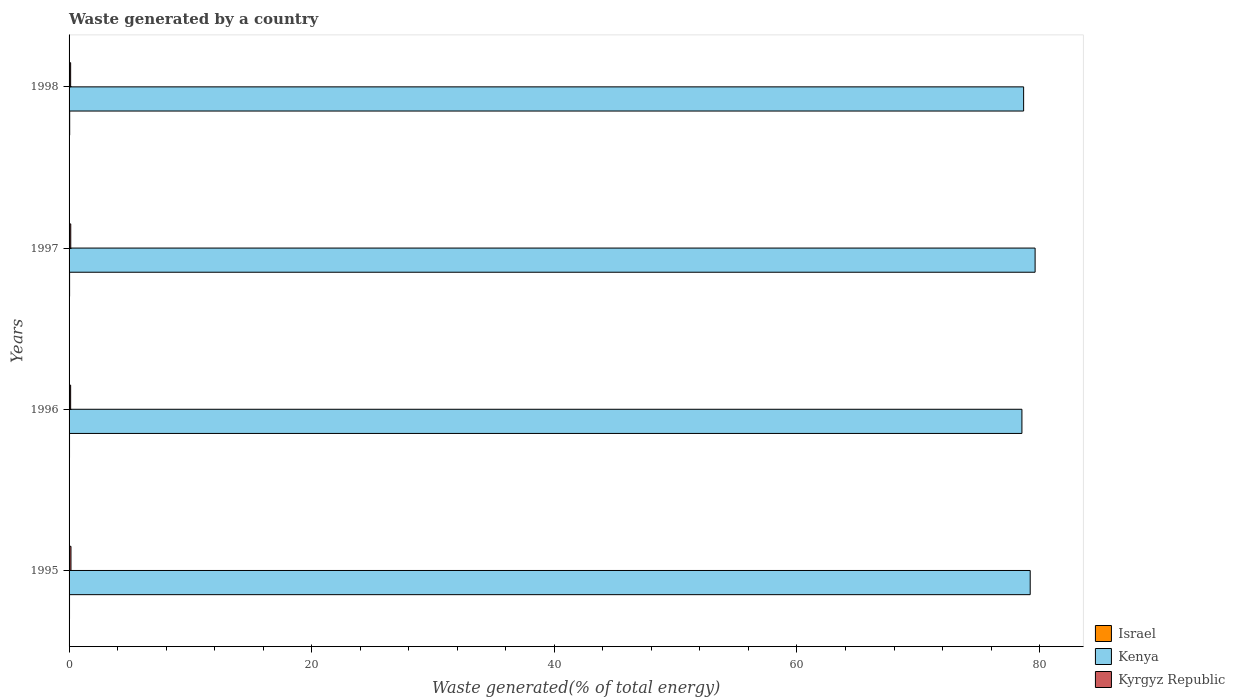How many different coloured bars are there?
Your answer should be compact. 3. Are the number of bars on each tick of the Y-axis equal?
Provide a succinct answer. Yes. How many bars are there on the 4th tick from the top?
Ensure brevity in your answer.  3. How many bars are there on the 3rd tick from the bottom?
Offer a very short reply. 3. In how many cases, is the number of bars for a given year not equal to the number of legend labels?
Offer a terse response. 0. What is the total waste generated in Kyrgyz Republic in 1997?
Your answer should be compact. 0.14. Across all years, what is the maximum total waste generated in Israel?
Provide a succinct answer. 0.05. Across all years, what is the minimum total waste generated in Kenya?
Make the answer very short. 78.55. In which year was the total waste generated in Kyrgyz Republic maximum?
Provide a succinct answer. 1995. What is the total total waste generated in Israel in the graph?
Provide a short and direct response. 0.17. What is the difference between the total waste generated in Israel in 1995 and that in 1996?
Provide a succinct answer. 0. What is the difference between the total waste generated in Kyrgyz Republic in 1995 and the total waste generated in Kenya in 1997?
Your response must be concise. -79.48. What is the average total waste generated in Kyrgyz Republic per year?
Provide a succinct answer. 0.14. In the year 1998, what is the difference between the total waste generated in Kyrgyz Republic and total waste generated in Kenya?
Your response must be concise. -78.56. In how many years, is the total waste generated in Israel greater than 60 %?
Your response must be concise. 0. What is the ratio of the total waste generated in Kenya in 1997 to that in 1998?
Provide a short and direct response. 1.01. What is the difference between the highest and the second highest total waste generated in Kenya?
Keep it short and to the point. 0.41. What is the difference between the highest and the lowest total waste generated in Israel?
Provide a succinct answer. 0.01. What does the 2nd bar from the top in 1997 represents?
Offer a very short reply. Kenya. Is it the case that in every year, the sum of the total waste generated in Kenya and total waste generated in Kyrgyz Republic is greater than the total waste generated in Israel?
Your response must be concise. Yes. Are all the bars in the graph horizontal?
Your answer should be compact. Yes. How many years are there in the graph?
Offer a very short reply. 4. Are the values on the major ticks of X-axis written in scientific E-notation?
Keep it short and to the point. No. How are the legend labels stacked?
Offer a very short reply. Vertical. What is the title of the graph?
Your answer should be compact. Waste generated by a country. What is the label or title of the X-axis?
Make the answer very short. Waste generated(% of total energy). What is the label or title of the Y-axis?
Provide a short and direct response. Years. What is the Waste generated(% of total energy) of Israel in 1995?
Give a very brief answer. 0.04. What is the Waste generated(% of total energy) of Kenya in 1995?
Your answer should be very brief. 79.23. What is the Waste generated(% of total energy) in Kyrgyz Republic in 1995?
Keep it short and to the point. 0.16. What is the Waste generated(% of total energy) of Israel in 1996?
Make the answer very short. 0.04. What is the Waste generated(% of total energy) in Kenya in 1996?
Make the answer very short. 78.55. What is the Waste generated(% of total energy) of Kyrgyz Republic in 1996?
Ensure brevity in your answer.  0.13. What is the Waste generated(% of total energy) in Israel in 1997?
Your answer should be compact. 0.04. What is the Waste generated(% of total energy) in Kenya in 1997?
Offer a very short reply. 79.63. What is the Waste generated(% of total energy) in Kyrgyz Republic in 1997?
Give a very brief answer. 0.14. What is the Waste generated(% of total energy) in Israel in 1998?
Your response must be concise. 0.05. What is the Waste generated(% of total energy) in Kenya in 1998?
Ensure brevity in your answer.  78.69. What is the Waste generated(% of total energy) in Kyrgyz Republic in 1998?
Give a very brief answer. 0.13. Across all years, what is the maximum Waste generated(% of total energy) of Israel?
Offer a terse response. 0.05. Across all years, what is the maximum Waste generated(% of total energy) in Kenya?
Ensure brevity in your answer.  79.63. Across all years, what is the maximum Waste generated(% of total energy) of Kyrgyz Republic?
Offer a terse response. 0.16. Across all years, what is the minimum Waste generated(% of total energy) in Israel?
Your answer should be very brief. 0.04. Across all years, what is the minimum Waste generated(% of total energy) in Kenya?
Give a very brief answer. 78.55. Across all years, what is the minimum Waste generated(% of total energy) in Kyrgyz Republic?
Offer a very short reply. 0.13. What is the total Waste generated(% of total energy) in Israel in the graph?
Provide a succinct answer. 0.17. What is the total Waste generated(% of total energy) in Kenya in the graph?
Your response must be concise. 316.09. What is the total Waste generated(% of total energy) of Kyrgyz Republic in the graph?
Ensure brevity in your answer.  0.55. What is the difference between the Waste generated(% of total energy) of Israel in 1995 and that in 1996?
Give a very brief answer. 0. What is the difference between the Waste generated(% of total energy) of Kenya in 1995 and that in 1996?
Keep it short and to the point. 0.68. What is the difference between the Waste generated(% of total energy) of Kyrgyz Republic in 1995 and that in 1996?
Ensure brevity in your answer.  0.03. What is the difference between the Waste generated(% of total energy) of Israel in 1995 and that in 1997?
Your response must be concise. -0. What is the difference between the Waste generated(% of total energy) in Kenya in 1995 and that in 1997?
Keep it short and to the point. -0.41. What is the difference between the Waste generated(% of total energy) in Kyrgyz Republic in 1995 and that in 1997?
Ensure brevity in your answer.  0.02. What is the difference between the Waste generated(% of total energy) of Israel in 1995 and that in 1998?
Provide a short and direct response. -0.01. What is the difference between the Waste generated(% of total energy) of Kenya in 1995 and that in 1998?
Ensure brevity in your answer.  0.54. What is the difference between the Waste generated(% of total energy) in Kyrgyz Republic in 1995 and that in 1998?
Keep it short and to the point. 0.03. What is the difference between the Waste generated(% of total energy) of Israel in 1996 and that in 1997?
Provide a short and direct response. -0.01. What is the difference between the Waste generated(% of total energy) of Kenya in 1996 and that in 1997?
Give a very brief answer. -1.09. What is the difference between the Waste generated(% of total energy) in Kyrgyz Republic in 1996 and that in 1997?
Your answer should be very brief. -0.01. What is the difference between the Waste generated(% of total energy) in Israel in 1996 and that in 1998?
Your answer should be very brief. -0.01. What is the difference between the Waste generated(% of total energy) in Kenya in 1996 and that in 1998?
Your answer should be very brief. -0.14. What is the difference between the Waste generated(% of total energy) in Israel in 1997 and that in 1998?
Keep it short and to the point. -0.01. What is the difference between the Waste generated(% of total energy) of Kenya in 1997 and that in 1998?
Ensure brevity in your answer.  0.95. What is the difference between the Waste generated(% of total energy) of Kyrgyz Republic in 1997 and that in 1998?
Offer a terse response. 0.01. What is the difference between the Waste generated(% of total energy) in Israel in 1995 and the Waste generated(% of total energy) in Kenya in 1996?
Provide a short and direct response. -78.51. What is the difference between the Waste generated(% of total energy) in Israel in 1995 and the Waste generated(% of total energy) in Kyrgyz Republic in 1996?
Provide a short and direct response. -0.09. What is the difference between the Waste generated(% of total energy) in Kenya in 1995 and the Waste generated(% of total energy) in Kyrgyz Republic in 1996?
Offer a very short reply. 79.1. What is the difference between the Waste generated(% of total energy) of Israel in 1995 and the Waste generated(% of total energy) of Kenya in 1997?
Offer a very short reply. -79.59. What is the difference between the Waste generated(% of total energy) in Israel in 1995 and the Waste generated(% of total energy) in Kyrgyz Republic in 1997?
Give a very brief answer. -0.1. What is the difference between the Waste generated(% of total energy) of Kenya in 1995 and the Waste generated(% of total energy) of Kyrgyz Republic in 1997?
Your answer should be very brief. 79.09. What is the difference between the Waste generated(% of total energy) of Israel in 1995 and the Waste generated(% of total energy) of Kenya in 1998?
Give a very brief answer. -78.65. What is the difference between the Waste generated(% of total energy) in Israel in 1995 and the Waste generated(% of total energy) in Kyrgyz Republic in 1998?
Give a very brief answer. -0.09. What is the difference between the Waste generated(% of total energy) of Kenya in 1995 and the Waste generated(% of total energy) of Kyrgyz Republic in 1998?
Give a very brief answer. 79.1. What is the difference between the Waste generated(% of total energy) in Israel in 1996 and the Waste generated(% of total energy) in Kenya in 1997?
Offer a terse response. -79.6. What is the difference between the Waste generated(% of total energy) in Israel in 1996 and the Waste generated(% of total energy) in Kyrgyz Republic in 1997?
Offer a very short reply. -0.1. What is the difference between the Waste generated(% of total energy) of Kenya in 1996 and the Waste generated(% of total energy) of Kyrgyz Republic in 1997?
Ensure brevity in your answer.  78.41. What is the difference between the Waste generated(% of total energy) of Israel in 1996 and the Waste generated(% of total energy) of Kenya in 1998?
Your response must be concise. -78.65. What is the difference between the Waste generated(% of total energy) in Israel in 1996 and the Waste generated(% of total energy) in Kyrgyz Republic in 1998?
Provide a succinct answer. -0.09. What is the difference between the Waste generated(% of total energy) of Kenya in 1996 and the Waste generated(% of total energy) of Kyrgyz Republic in 1998?
Provide a short and direct response. 78.42. What is the difference between the Waste generated(% of total energy) of Israel in 1997 and the Waste generated(% of total energy) of Kenya in 1998?
Your answer should be very brief. -78.64. What is the difference between the Waste generated(% of total energy) of Israel in 1997 and the Waste generated(% of total energy) of Kyrgyz Republic in 1998?
Your response must be concise. -0.09. What is the difference between the Waste generated(% of total energy) of Kenya in 1997 and the Waste generated(% of total energy) of Kyrgyz Republic in 1998?
Provide a succinct answer. 79.5. What is the average Waste generated(% of total energy) in Israel per year?
Make the answer very short. 0.04. What is the average Waste generated(% of total energy) in Kenya per year?
Ensure brevity in your answer.  79.02. What is the average Waste generated(% of total energy) of Kyrgyz Republic per year?
Keep it short and to the point. 0.14. In the year 1995, what is the difference between the Waste generated(% of total energy) of Israel and Waste generated(% of total energy) of Kenya?
Ensure brevity in your answer.  -79.19. In the year 1995, what is the difference between the Waste generated(% of total energy) of Israel and Waste generated(% of total energy) of Kyrgyz Republic?
Your answer should be compact. -0.12. In the year 1995, what is the difference between the Waste generated(% of total energy) of Kenya and Waste generated(% of total energy) of Kyrgyz Republic?
Make the answer very short. 79.07. In the year 1996, what is the difference between the Waste generated(% of total energy) of Israel and Waste generated(% of total energy) of Kenya?
Offer a very short reply. -78.51. In the year 1996, what is the difference between the Waste generated(% of total energy) of Israel and Waste generated(% of total energy) of Kyrgyz Republic?
Your answer should be compact. -0.09. In the year 1996, what is the difference between the Waste generated(% of total energy) in Kenya and Waste generated(% of total energy) in Kyrgyz Republic?
Ensure brevity in your answer.  78.42. In the year 1997, what is the difference between the Waste generated(% of total energy) of Israel and Waste generated(% of total energy) of Kenya?
Offer a very short reply. -79.59. In the year 1997, what is the difference between the Waste generated(% of total energy) of Israel and Waste generated(% of total energy) of Kyrgyz Republic?
Provide a succinct answer. -0.09. In the year 1997, what is the difference between the Waste generated(% of total energy) of Kenya and Waste generated(% of total energy) of Kyrgyz Republic?
Offer a very short reply. 79.49. In the year 1998, what is the difference between the Waste generated(% of total energy) of Israel and Waste generated(% of total energy) of Kenya?
Give a very brief answer. -78.63. In the year 1998, what is the difference between the Waste generated(% of total energy) of Israel and Waste generated(% of total energy) of Kyrgyz Republic?
Give a very brief answer. -0.08. In the year 1998, what is the difference between the Waste generated(% of total energy) in Kenya and Waste generated(% of total energy) in Kyrgyz Republic?
Make the answer very short. 78.56. What is the ratio of the Waste generated(% of total energy) of Israel in 1995 to that in 1996?
Keep it short and to the point. 1.03. What is the ratio of the Waste generated(% of total energy) in Kenya in 1995 to that in 1996?
Provide a short and direct response. 1.01. What is the ratio of the Waste generated(% of total energy) of Kyrgyz Republic in 1995 to that in 1996?
Ensure brevity in your answer.  1.2. What is the ratio of the Waste generated(% of total energy) of Israel in 1995 to that in 1997?
Make the answer very short. 0.89. What is the ratio of the Waste generated(% of total energy) in Kyrgyz Republic in 1995 to that in 1997?
Provide a succinct answer. 1.13. What is the ratio of the Waste generated(% of total energy) of Israel in 1995 to that in 1998?
Your response must be concise. 0.76. What is the ratio of the Waste generated(% of total energy) in Kyrgyz Republic in 1995 to that in 1998?
Provide a short and direct response. 1.2. What is the ratio of the Waste generated(% of total energy) of Israel in 1996 to that in 1997?
Make the answer very short. 0.86. What is the ratio of the Waste generated(% of total energy) in Kenya in 1996 to that in 1997?
Keep it short and to the point. 0.99. What is the ratio of the Waste generated(% of total energy) of Kyrgyz Republic in 1996 to that in 1997?
Your answer should be very brief. 0.94. What is the ratio of the Waste generated(% of total energy) in Israel in 1996 to that in 1998?
Offer a terse response. 0.74. What is the ratio of the Waste generated(% of total energy) in Kenya in 1996 to that in 1998?
Your response must be concise. 1. What is the ratio of the Waste generated(% of total energy) of Israel in 1997 to that in 1998?
Make the answer very short. 0.85. What is the ratio of the Waste generated(% of total energy) in Kyrgyz Republic in 1997 to that in 1998?
Offer a terse response. 1.06. What is the difference between the highest and the second highest Waste generated(% of total energy) of Israel?
Give a very brief answer. 0.01. What is the difference between the highest and the second highest Waste generated(% of total energy) in Kenya?
Provide a short and direct response. 0.41. What is the difference between the highest and the second highest Waste generated(% of total energy) of Kyrgyz Republic?
Offer a very short reply. 0.02. What is the difference between the highest and the lowest Waste generated(% of total energy) in Israel?
Offer a very short reply. 0.01. What is the difference between the highest and the lowest Waste generated(% of total energy) of Kenya?
Make the answer very short. 1.09. What is the difference between the highest and the lowest Waste generated(% of total energy) of Kyrgyz Republic?
Make the answer very short. 0.03. 